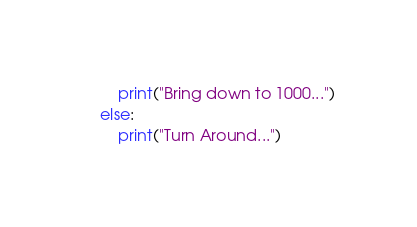<code> <loc_0><loc_0><loc_500><loc_500><_Python_>        print("Bring down to 1000...")
    else:
        print("Turn Around...")</code> 